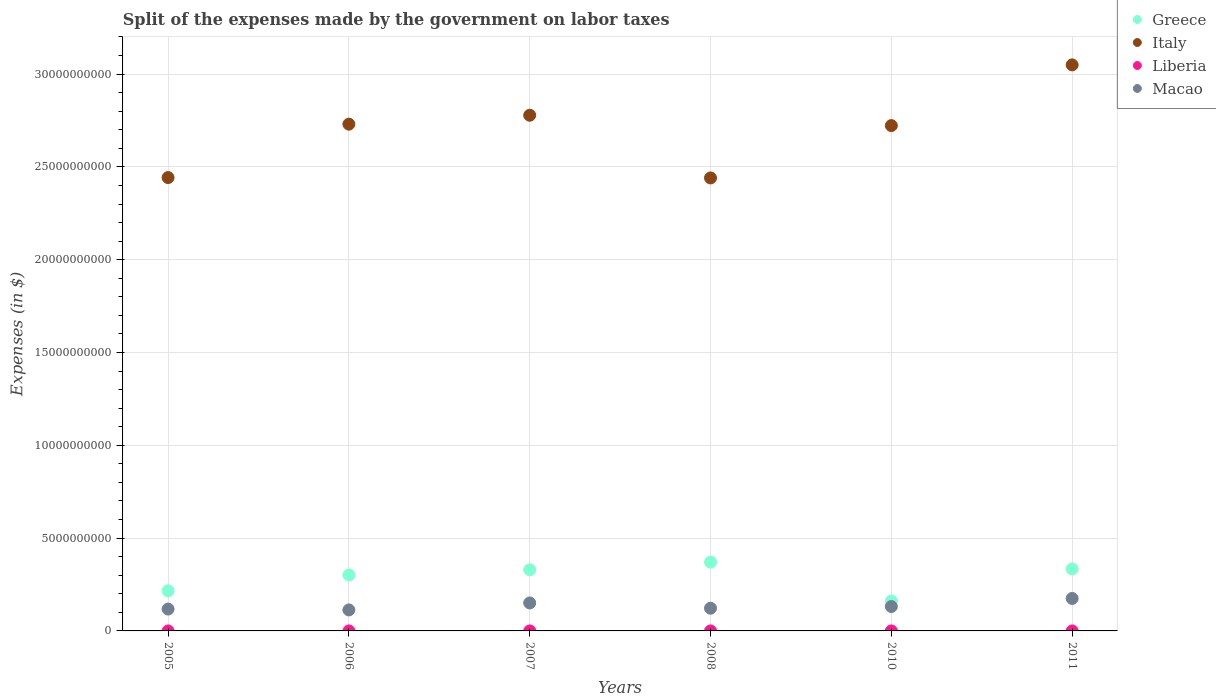How many different coloured dotlines are there?
Your response must be concise. 4. What is the expenses made by the government on labor taxes in Macao in 2010?
Make the answer very short. 1.31e+09. Across all years, what is the maximum expenses made by the government on labor taxes in Liberia?
Your answer should be very brief. 1.84e+05. Across all years, what is the minimum expenses made by the government on labor taxes in Macao?
Provide a short and direct response. 1.13e+09. In which year was the expenses made by the government on labor taxes in Liberia maximum?
Provide a short and direct response. 2010. What is the total expenses made by the government on labor taxes in Liberia in the graph?
Your answer should be very brief. 4.01e+05. What is the difference between the expenses made by the government on labor taxes in Macao in 2006 and that in 2007?
Offer a terse response. -3.76e+08. What is the difference between the expenses made by the government on labor taxes in Greece in 2006 and the expenses made by the government on labor taxes in Liberia in 2007?
Give a very brief answer. 3.01e+09. What is the average expenses made by the government on labor taxes in Italy per year?
Offer a very short reply. 2.69e+1. In the year 2011, what is the difference between the expenses made by the government on labor taxes in Liberia and expenses made by the government on labor taxes in Italy?
Give a very brief answer. -3.05e+1. In how many years, is the expenses made by the government on labor taxes in Macao greater than 19000000000 $?
Offer a terse response. 0. What is the ratio of the expenses made by the government on labor taxes in Italy in 2008 to that in 2010?
Give a very brief answer. 0.9. What is the difference between the highest and the second highest expenses made by the government on labor taxes in Macao?
Provide a succinct answer. 2.42e+08. What is the difference between the highest and the lowest expenses made by the government on labor taxes in Macao?
Your answer should be compact. 6.18e+08. Does the expenses made by the government on labor taxes in Italy monotonically increase over the years?
Ensure brevity in your answer.  No. How many years are there in the graph?
Give a very brief answer. 6. What is the difference between two consecutive major ticks on the Y-axis?
Your answer should be compact. 5.00e+09. Are the values on the major ticks of Y-axis written in scientific E-notation?
Make the answer very short. No. Does the graph contain any zero values?
Your response must be concise. No. Does the graph contain grids?
Ensure brevity in your answer.  Yes. How many legend labels are there?
Ensure brevity in your answer.  4. What is the title of the graph?
Keep it short and to the point. Split of the expenses made by the government on labor taxes. What is the label or title of the X-axis?
Provide a succinct answer. Years. What is the label or title of the Y-axis?
Give a very brief answer. Expenses (in $). What is the Expenses (in $) of Greece in 2005?
Keep it short and to the point. 2.16e+09. What is the Expenses (in $) in Italy in 2005?
Your answer should be very brief. 2.44e+1. What is the Expenses (in $) in Liberia in 2005?
Your response must be concise. 5831.56. What is the Expenses (in $) of Macao in 2005?
Offer a very short reply. 1.18e+09. What is the Expenses (in $) in Greece in 2006?
Offer a very short reply. 3.01e+09. What is the Expenses (in $) in Italy in 2006?
Ensure brevity in your answer.  2.73e+1. What is the Expenses (in $) in Liberia in 2006?
Your response must be concise. 4798.07. What is the Expenses (in $) in Macao in 2006?
Provide a succinct answer. 1.13e+09. What is the Expenses (in $) in Greece in 2007?
Ensure brevity in your answer.  3.29e+09. What is the Expenses (in $) of Italy in 2007?
Your answer should be compact. 2.78e+1. What is the Expenses (in $) of Liberia in 2007?
Offer a very short reply. 1.49e+04. What is the Expenses (in $) in Macao in 2007?
Your answer should be compact. 1.51e+09. What is the Expenses (in $) of Greece in 2008?
Your response must be concise. 3.71e+09. What is the Expenses (in $) of Italy in 2008?
Make the answer very short. 2.44e+1. What is the Expenses (in $) in Liberia in 2008?
Provide a succinct answer. 2.34e+04. What is the Expenses (in $) in Macao in 2008?
Offer a very short reply. 1.22e+09. What is the Expenses (in $) of Greece in 2010?
Your answer should be very brief. 1.61e+09. What is the Expenses (in $) of Italy in 2010?
Offer a terse response. 2.72e+1. What is the Expenses (in $) in Liberia in 2010?
Ensure brevity in your answer.  1.84e+05. What is the Expenses (in $) in Macao in 2010?
Your answer should be compact. 1.31e+09. What is the Expenses (in $) in Greece in 2011?
Your response must be concise. 3.34e+09. What is the Expenses (in $) of Italy in 2011?
Provide a short and direct response. 3.05e+1. What is the Expenses (in $) of Liberia in 2011?
Make the answer very short. 1.69e+05. What is the Expenses (in $) in Macao in 2011?
Ensure brevity in your answer.  1.75e+09. Across all years, what is the maximum Expenses (in $) of Greece?
Your answer should be very brief. 3.71e+09. Across all years, what is the maximum Expenses (in $) in Italy?
Provide a succinct answer. 3.05e+1. Across all years, what is the maximum Expenses (in $) in Liberia?
Offer a terse response. 1.84e+05. Across all years, what is the maximum Expenses (in $) in Macao?
Offer a very short reply. 1.75e+09. Across all years, what is the minimum Expenses (in $) of Greece?
Offer a terse response. 1.61e+09. Across all years, what is the minimum Expenses (in $) of Italy?
Give a very brief answer. 2.44e+1. Across all years, what is the minimum Expenses (in $) in Liberia?
Your answer should be very brief. 4798.07. Across all years, what is the minimum Expenses (in $) of Macao?
Ensure brevity in your answer.  1.13e+09. What is the total Expenses (in $) of Greece in the graph?
Give a very brief answer. 1.71e+1. What is the total Expenses (in $) in Italy in the graph?
Ensure brevity in your answer.  1.62e+11. What is the total Expenses (in $) in Liberia in the graph?
Ensure brevity in your answer.  4.01e+05. What is the total Expenses (in $) in Macao in the graph?
Your answer should be very brief. 8.10e+09. What is the difference between the Expenses (in $) of Greece in 2005 and that in 2006?
Keep it short and to the point. -8.53e+08. What is the difference between the Expenses (in $) of Italy in 2005 and that in 2006?
Your response must be concise. -2.88e+09. What is the difference between the Expenses (in $) in Liberia in 2005 and that in 2006?
Offer a very short reply. 1033.49. What is the difference between the Expenses (in $) in Macao in 2005 and that in 2006?
Offer a terse response. 4.80e+07. What is the difference between the Expenses (in $) in Greece in 2005 and that in 2007?
Your answer should be very brief. -1.13e+09. What is the difference between the Expenses (in $) in Italy in 2005 and that in 2007?
Ensure brevity in your answer.  -3.36e+09. What is the difference between the Expenses (in $) of Liberia in 2005 and that in 2007?
Your response must be concise. -9055.06. What is the difference between the Expenses (in $) of Macao in 2005 and that in 2007?
Offer a very short reply. -3.28e+08. What is the difference between the Expenses (in $) of Greece in 2005 and that in 2008?
Offer a very short reply. -1.55e+09. What is the difference between the Expenses (in $) of Italy in 2005 and that in 2008?
Your answer should be compact. 1.90e+07. What is the difference between the Expenses (in $) of Liberia in 2005 and that in 2008?
Your response must be concise. -1.76e+04. What is the difference between the Expenses (in $) in Macao in 2005 and that in 2008?
Your answer should be very brief. -4.48e+07. What is the difference between the Expenses (in $) of Greece in 2005 and that in 2010?
Ensure brevity in your answer.  5.49e+08. What is the difference between the Expenses (in $) in Italy in 2005 and that in 2010?
Your response must be concise. -2.80e+09. What is the difference between the Expenses (in $) in Liberia in 2005 and that in 2010?
Make the answer very short. -1.78e+05. What is the difference between the Expenses (in $) of Macao in 2005 and that in 2010?
Make the answer very short. -1.35e+08. What is the difference between the Expenses (in $) in Greece in 2005 and that in 2011?
Your answer should be compact. -1.18e+09. What is the difference between the Expenses (in $) of Italy in 2005 and that in 2011?
Provide a short and direct response. -6.07e+09. What is the difference between the Expenses (in $) in Liberia in 2005 and that in 2011?
Keep it short and to the point. -1.63e+05. What is the difference between the Expenses (in $) of Macao in 2005 and that in 2011?
Provide a short and direct response. -5.70e+08. What is the difference between the Expenses (in $) of Greece in 2006 and that in 2007?
Offer a terse response. -2.81e+08. What is the difference between the Expenses (in $) of Italy in 2006 and that in 2007?
Give a very brief answer. -4.80e+08. What is the difference between the Expenses (in $) of Liberia in 2006 and that in 2007?
Keep it short and to the point. -1.01e+04. What is the difference between the Expenses (in $) in Macao in 2006 and that in 2007?
Your answer should be compact. -3.76e+08. What is the difference between the Expenses (in $) of Greece in 2006 and that in 2008?
Your answer should be very brief. -6.94e+08. What is the difference between the Expenses (in $) of Italy in 2006 and that in 2008?
Your answer should be very brief. 2.90e+09. What is the difference between the Expenses (in $) of Liberia in 2006 and that in 2008?
Offer a terse response. -1.86e+04. What is the difference between the Expenses (in $) of Macao in 2006 and that in 2008?
Offer a terse response. -9.28e+07. What is the difference between the Expenses (in $) in Greece in 2006 and that in 2010?
Your answer should be compact. 1.40e+09. What is the difference between the Expenses (in $) of Italy in 2006 and that in 2010?
Provide a short and direct response. 7.70e+07. What is the difference between the Expenses (in $) in Liberia in 2006 and that in 2010?
Your response must be concise. -1.79e+05. What is the difference between the Expenses (in $) of Macao in 2006 and that in 2010?
Make the answer very short. -1.83e+08. What is the difference between the Expenses (in $) in Greece in 2006 and that in 2011?
Provide a short and direct response. -3.28e+08. What is the difference between the Expenses (in $) of Italy in 2006 and that in 2011?
Offer a terse response. -3.19e+09. What is the difference between the Expenses (in $) of Liberia in 2006 and that in 2011?
Keep it short and to the point. -1.64e+05. What is the difference between the Expenses (in $) in Macao in 2006 and that in 2011?
Your response must be concise. -6.18e+08. What is the difference between the Expenses (in $) of Greece in 2007 and that in 2008?
Your answer should be very brief. -4.13e+08. What is the difference between the Expenses (in $) of Italy in 2007 and that in 2008?
Give a very brief answer. 3.38e+09. What is the difference between the Expenses (in $) of Liberia in 2007 and that in 2008?
Offer a terse response. -8521.28. What is the difference between the Expenses (in $) of Macao in 2007 and that in 2008?
Provide a short and direct response. 2.83e+08. What is the difference between the Expenses (in $) in Greece in 2007 and that in 2010?
Offer a very short reply. 1.68e+09. What is the difference between the Expenses (in $) of Italy in 2007 and that in 2010?
Ensure brevity in your answer.  5.57e+08. What is the difference between the Expenses (in $) in Liberia in 2007 and that in 2010?
Provide a succinct answer. -1.69e+05. What is the difference between the Expenses (in $) of Macao in 2007 and that in 2010?
Provide a short and direct response. 1.93e+08. What is the difference between the Expenses (in $) of Greece in 2007 and that in 2011?
Your answer should be very brief. -4.70e+07. What is the difference between the Expenses (in $) of Italy in 2007 and that in 2011?
Ensure brevity in your answer.  -2.71e+09. What is the difference between the Expenses (in $) of Liberia in 2007 and that in 2011?
Offer a very short reply. -1.54e+05. What is the difference between the Expenses (in $) in Macao in 2007 and that in 2011?
Offer a terse response. -2.42e+08. What is the difference between the Expenses (in $) of Greece in 2008 and that in 2010?
Give a very brief answer. 2.10e+09. What is the difference between the Expenses (in $) of Italy in 2008 and that in 2010?
Keep it short and to the point. -2.82e+09. What is the difference between the Expenses (in $) of Liberia in 2008 and that in 2010?
Give a very brief answer. -1.61e+05. What is the difference between the Expenses (in $) in Macao in 2008 and that in 2010?
Your answer should be very brief. -9.05e+07. What is the difference between the Expenses (in $) in Greece in 2008 and that in 2011?
Make the answer very short. 3.66e+08. What is the difference between the Expenses (in $) in Italy in 2008 and that in 2011?
Keep it short and to the point. -6.09e+09. What is the difference between the Expenses (in $) of Liberia in 2008 and that in 2011?
Your response must be concise. -1.45e+05. What is the difference between the Expenses (in $) of Macao in 2008 and that in 2011?
Offer a terse response. -5.25e+08. What is the difference between the Expenses (in $) of Greece in 2010 and that in 2011?
Keep it short and to the point. -1.73e+09. What is the difference between the Expenses (in $) in Italy in 2010 and that in 2011?
Your answer should be compact. -3.27e+09. What is the difference between the Expenses (in $) of Liberia in 2010 and that in 2011?
Provide a succinct answer. 1.55e+04. What is the difference between the Expenses (in $) of Macao in 2010 and that in 2011?
Make the answer very short. -4.35e+08. What is the difference between the Expenses (in $) of Greece in 2005 and the Expenses (in $) of Italy in 2006?
Provide a succinct answer. -2.51e+1. What is the difference between the Expenses (in $) in Greece in 2005 and the Expenses (in $) in Liberia in 2006?
Provide a short and direct response. 2.16e+09. What is the difference between the Expenses (in $) in Greece in 2005 and the Expenses (in $) in Macao in 2006?
Give a very brief answer. 1.03e+09. What is the difference between the Expenses (in $) of Italy in 2005 and the Expenses (in $) of Liberia in 2006?
Provide a succinct answer. 2.44e+1. What is the difference between the Expenses (in $) of Italy in 2005 and the Expenses (in $) of Macao in 2006?
Ensure brevity in your answer.  2.33e+1. What is the difference between the Expenses (in $) of Liberia in 2005 and the Expenses (in $) of Macao in 2006?
Your answer should be compact. -1.13e+09. What is the difference between the Expenses (in $) in Greece in 2005 and the Expenses (in $) in Italy in 2007?
Provide a short and direct response. -2.56e+1. What is the difference between the Expenses (in $) of Greece in 2005 and the Expenses (in $) of Liberia in 2007?
Provide a short and direct response. 2.16e+09. What is the difference between the Expenses (in $) in Greece in 2005 and the Expenses (in $) in Macao in 2007?
Your answer should be compact. 6.53e+08. What is the difference between the Expenses (in $) in Italy in 2005 and the Expenses (in $) in Liberia in 2007?
Your answer should be compact. 2.44e+1. What is the difference between the Expenses (in $) in Italy in 2005 and the Expenses (in $) in Macao in 2007?
Your answer should be very brief. 2.29e+1. What is the difference between the Expenses (in $) of Liberia in 2005 and the Expenses (in $) of Macao in 2007?
Keep it short and to the point. -1.51e+09. What is the difference between the Expenses (in $) in Greece in 2005 and the Expenses (in $) in Italy in 2008?
Provide a short and direct response. -2.22e+1. What is the difference between the Expenses (in $) of Greece in 2005 and the Expenses (in $) of Liberia in 2008?
Offer a very short reply. 2.16e+09. What is the difference between the Expenses (in $) in Greece in 2005 and the Expenses (in $) in Macao in 2008?
Provide a short and direct response. 9.36e+08. What is the difference between the Expenses (in $) in Italy in 2005 and the Expenses (in $) in Liberia in 2008?
Your response must be concise. 2.44e+1. What is the difference between the Expenses (in $) of Italy in 2005 and the Expenses (in $) of Macao in 2008?
Offer a very short reply. 2.32e+1. What is the difference between the Expenses (in $) of Liberia in 2005 and the Expenses (in $) of Macao in 2008?
Your answer should be compact. -1.22e+09. What is the difference between the Expenses (in $) in Greece in 2005 and the Expenses (in $) in Italy in 2010?
Your answer should be compact. -2.51e+1. What is the difference between the Expenses (in $) of Greece in 2005 and the Expenses (in $) of Liberia in 2010?
Give a very brief answer. 2.16e+09. What is the difference between the Expenses (in $) of Greece in 2005 and the Expenses (in $) of Macao in 2010?
Ensure brevity in your answer.  8.46e+08. What is the difference between the Expenses (in $) in Italy in 2005 and the Expenses (in $) in Liberia in 2010?
Your answer should be compact. 2.44e+1. What is the difference between the Expenses (in $) of Italy in 2005 and the Expenses (in $) of Macao in 2010?
Make the answer very short. 2.31e+1. What is the difference between the Expenses (in $) in Liberia in 2005 and the Expenses (in $) in Macao in 2010?
Make the answer very short. -1.31e+09. What is the difference between the Expenses (in $) in Greece in 2005 and the Expenses (in $) in Italy in 2011?
Ensure brevity in your answer.  -2.83e+1. What is the difference between the Expenses (in $) in Greece in 2005 and the Expenses (in $) in Liberia in 2011?
Make the answer very short. 2.16e+09. What is the difference between the Expenses (in $) in Greece in 2005 and the Expenses (in $) in Macao in 2011?
Make the answer very short. 4.11e+08. What is the difference between the Expenses (in $) in Italy in 2005 and the Expenses (in $) in Liberia in 2011?
Your response must be concise. 2.44e+1. What is the difference between the Expenses (in $) in Italy in 2005 and the Expenses (in $) in Macao in 2011?
Your answer should be compact. 2.27e+1. What is the difference between the Expenses (in $) in Liberia in 2005 and the Expenses (in $) in Macao in 2011?
Provide a succinct answer. -1.75e+09. What is the difference between the Expenses (in $) of Greece in 2006 and the Expenses (in $) of Italy in 2007?
Provide a short and direct response. -2.48e+1. What is the difference between the Expenses (in $) in Greece in 2006 and the Expenses (in $) in Liberia in 2007?
Ensure brevity in your answer.  3.01e+09. What is the difference between the Expenses (in $) in Greece in 2006 and the Expenses (in $) in Macao in 2007?
Give a very brief answer. 1.51e+09. What is the difference between the Expenses (in $) in Italy in 2006 and the Expenses (in $) in Liberia in 2007?
Your answer should be compact. 2.73e+1. What is the difference between the Expenses (in $) in Italy in 2006 and the Expenses (in $) in Macao in 2007?
Provide a succinct answer. 2.58e+1. What is the difference between the Expenses (in $) in Liberia in 2006 and the Expenses (in $) in Macao in 2007?
Ensure brevity in your answer.  -1.51e+09. What is the difference between the Expenses (in $) in Greece in 2006 and the Expenses (in $) in Italy in 2008?
Give a very brief answer. -2.14e+1. What is the difference between the Expenses (in $) in Greece in 2006 and the Expenses (in $) in Liberia in 2008?
Your answer should be compact. 3.01e+09. What is the difference between the Expenses (in $) in Greece in 2006 and the Expenses (in $) in Macao in 2008?
Offer a very short reply. 1.79e+09. What is the difference between the Expenses (in $) of Italy in 2006 and the Expenses (in $) of Liberia in 2008?
Your answer should be compact. 2.73e+1. What is the difference between the Expenses (in $) in Italy in 2006 and the Expenses (in $) in Macao in 2008?
Provide a short and direct response. 2.61e+1. What is the difference between the Expenses (in $) of Liberia in 2006 and the Expenses (in $) of Macao in 2008?
Your answer should be compact. -1.22e+09. What is the difference between the Expenses (in $) of Greece in 2006 and the Expenses (in $) of Italy in 2010?
Provide a succinct answer. -2.42e+1. What is the difference between the Expenses (in $) in Greece in 2006 and the Expenses (in $) in Liberia in 2010?
Give a very brief answer. 3.01e+09. What is the difference between the Expenses (in $) in Greece in 2006 and the Expenses (in $) in Macao in 2010?
Provide a short and direct response. 1.70e+09. What is the difference between the Expenses (in $) of Italy in 2006 and the Expenses (in $) of Liberia in 2010?
Your response must be concise. 2.73e+1. What is the difference between the Expenses (in $) in Italy in 2006 and the Expenses (in $) in Macao in 2010?
Your response must be concise. 2.60e+1. What is the difference between the Expenses (in $) of Liberia in 2006 and the Expenses (in $) of Macao in 2010?
Give a very brief answer. -1.31e+09. What is the difference between the Expenses (in $) of Greece in 2006 and the Expenses (in $) of Italy in 2011?
Ensure brevity in your answer.  -2.75e+1. What is the difference between the Expenses (in $) in Greece in 2006 and the Expenses (in $) in Liberia in 2011?
Provide a short and direct response. 3.01e+09. What is the difference between the Expenses (in $) in Greece in 2006 and the Expenses (in $) in Macao in 2011?
Make the answer very short. 1.26e+09. What is the difference between the Expenses (in $) of Italy in 2006 and the Expenses (in $) of Liberia in 2011?
Keep it short and to the point. 2.73e+1. What is the difference between the Expenses (in $) in Italy in 2006 and the Expenses (in $) in Macao in 2011?
Your answer should be compact. 2.56e+1. What is the difference between the Expenses (in $) of Liberia in 2006 and the Expenses (in $) of Macao in 2011?
Provide a succinct answer. -1.75e+09. What is the difference between the Expenses (in $) of Greece in 2007 and the Expenses (in $) of Italy in 2008?
Your answer should be very brief. -2.11e+1. What is the difference between the Expenses (in $) in Greece in 2007 and the Expenses (in $) in Liberia in 2008?
Your answer should be compact. 3.29e+09. What is the difference between the Expenses (in $) of Greece in 2007 and the Expenses (in $) of Macao in 2008?
Give a very brief answer. 2.07e+09. What is the difference between the Expenses (in $) of Italy in 2007 and the Expenses (in $) of Liberia in 2008?
Keep it short and to the point. 2.78e+1. What is the difference between the Expenses (in $) in Italy in 2007 and the Expenses (in $) in Macao in 2008?
Ensure brevity in your answer.  2.66e+1. What is the difference between the Expenses (in $) of Liberia in 2007 and the Expenses (in $) of Macao in 2008?
Ensure brevity in your answer.  -1.22e+09. What is the difference between the Expenses (in $) of Greece in 2007 and the Expenses (in $) of Italy in 2010?
Your response must be concise. -2.39e+1. What is the difference between the Expenses (in $) in Greece in 2007 and the Expenses (in $) in Liberia in 2010?
Ensure brevity in your answer.  3.29e+09. What is the difference between the Expenses (in $) in Greece in 2007 and the Expenses (in $) in Macao in 2010?
Provide a succinct answer. 1.98e+09. What is the difference between the Expenses (in $) of Italy in 2007 and the Expenses (in $) of Liberia in 2010?
Offer a very short reply. 2.78e+1. What is the difference between the Expenses (in $) of Italy in 2007 and the Expenses (in $) of Macao in 2010?
Ensure brevity in your answer.  2.65e+1. What is the difference between the Expenses (in $) in Liberia in 2007 and the Expenses (in $) in Macao in 2010?
Give a very brief answer. -1.31e+09. What is the difference between the Expenses (in $) of Greece in 2007 and the Expenses (in $) of Italy in 2011?
Offer a very short reply. -2.72e+1. What is the difference between the Expenses (in $) of Greece in 2007 and the Expenses (in $) of Liberia in 2011?
Provide a succinct answer. 3.29e+09. What is the difference between the Expenses (in $) in Greece in 2007 and the Expenses (in $) in Macao in 2011?
Give a very brief answer. 1.54e+09. What is the difference between the Expenses (in $) in Italy in 2007 and the Expenses (in $) in Liberia in 2011?
Give a very brief answer. 2.78e+1. What is the difference between the Expenses (in $) in Italy in 2007 and the Expenses (in $) in Macao in 2011?
Give a very brief answer. 2.60e+1. What is the difference between the Expenses (in $) in Liberia in 2007 and the Expenses (in $) in Macao in 2011?
Give a very brief answer. -1.75e+09. What is the difference between the Expenses (in $) in Greece in 2008 and the Expenses (in $) in Italy in 2010?
Ensure brevity in your answer.  -2.35e+1. What is the difference between the Expenses (in $) of Greece in 2008 and the Expenses (in $) of Liberia in 2010?
Offer a terse response. 3.71e+09. What is the difference between the Expenses (in $) in Greece in 2008 and the Expenses (in $) in Macao in 2010?
Ensure brevity in your answer.  2.39e+09. What is the difference between the Expenses (in $) in Italy in 2008 and the Expenses (in $) in Liberia in 2010?
Your answer should be very brief. 2.44e+1. What is the difference between the Expenses (in $) in Italy in 2008 and the Expenses (in $) in Macao in 2010?
Provide a succinct answer. 2.31e+1. What is the difference between the Expenses (in $) in Liberia in 2008 and the Expenses (in $) in Macao in 2010?
Your response must be concise. -1.31e+09. What is the difference between the Expenses (in $) in Greece in 2008 and the Expenses (in $) in Italy in 2011?
Offer a terse response. -2.68e+1. What is the difference between the Expenses (in $) in Greece in 2008 and the Expenses (in $) in Liberia in 2011?
Provide a short and direct response. 3.71e+09. What is the difference between the Expenses (in $) of Greece in 2008 and the Expenses (in $) of Macao in 2011?
Ensure brevity in your answer.  1.96e+09. What is the difference between the Expenses (in $) of Italy in 2008 and the Expenses (in $) of Liberia in 2011?
Provide a succinct answer. 2.44e+1. What is the difference between the Expenses (in $) of Italy in 2008 and the Expenses (in $) of Macao in 2011?
Give a very brief answer. 2.27e+1. What is the difference between the Expenses (in $) in Liberia in 2008 and the Expenses (in $) in Macao in 2011?
Ensure brevity in your answer.  -1.75e+09. What is the difference between the Expenses (in $) in Greece in 2010 and the Expenses (in $) in Italy in 2011?
Offer a very short reply. -2.89e+1. What is the difference between the Expenses (in $) in Greece in 2010 and the Expenses (in $) in Liberia in 2011?
Your response must be concise. 1.61e+09. What is the difference between the Expenses (in $) in Greece in 2010 and the Expenses (in $) in Macao in 2011?
Your response must be concise. -1.38e+08. What is the difference between the Expenses (in $) in Italy in 2010 and the Expenses (in $) in Liberia in 2011?
Your answer should be very brief. 2.72e+1. What is the difference between the Expenses (in $) in Italy in 2010 and the Expenses (in $) in Macao in 2011?
Make the answer very short. 2.55e+1. What is the difference between the Expenses (in $) of Liberia in 2010 and the Expenses (in $) of Macao in 2011?
Your response must be concise. -1.75e+09. What is the average Expenses (in $) in Greece per year?
Your answer should be very brief. 2.85e+09. What is the average Expenses (in $) of Italy per year?
Make the answer very short. 2.69e+1. What is the average Expenses (in $) of Liberia per year?
Provide a succinct answer. 6.69e+04. What is the average Expenses (in $) in Macao per year?
Provide a succinct answer. 1.35e+09. In the year 2005, what is the difference between the Expenses (in $) of Greece and Expenses (in $) of Italy?
Your answer should be compact. -2.23e+1. In the year 2005, what is the difference between the Expenses (in $) in Greece and Expenses (in $) in Liberia?
Give a very brief answer. 2.16e+09. In the year 2005, what is the difference between the Expenses (in $) in Greece and Expenses (in $) in Macao?
Provide a short and direct response. 9.81e+08. In the year 2005, what is the difference between the Expenses (in $) in Italy and Expenses (in $) in Liberia?
Ensure brevity in your answer.  2.44e+1. In the year 2005, what is the difference between the Expenses (in $) in Italy and Expenses (in $) in Macao?
Offer a very short reply. 2.32e+1. In the year 2005, what is the difference between the Expenses (in $) of Liberia and Expenses (in $) of Macao?
Offer a terse response. -1.18e+09. In the year 2006, what is the difference between the Expenses (in $) of Greece and Expenses (in $) of Italy?
Your answer should be very brief. -2.43e+1. In the year 2006, what is the difference between the Expenses (in $) of Greece and Expenses (in $) of Liberia?
Your answer should be compact. 3.01e+09. In the year 2006, what is the difference between the Expenses (in $) of Greece and Expenses (in $) of Macao?
Provide a succinct answer. 1.88e+09. In the year 2006, what is the difference between the Expenses (in $) in Italy and Expenses (in $) in Liberia?
Make the answer very short. 2.73e+1. In the year 2006, what is the difference between the Expenses (in $) of Italy and Expenses (in $) of Macao?
Make the answer very short. 2.62e+1. In the year 2006, what is the difference between the Expenses (in $) in Liberia and Expenses (in $) in Macao?
Your answer should be very brief. -1.13e+09. In the year 2007, what is the difference between the Expenses (in $) of Greece and Expenses (in $) of Italy?
Make the answer very short. -2.45e+1. In the year 2007, what is the difference between the Expenses (in $) in Greece and Expenses (in $) in Liberia?
Offer a very short reply. 3.29e+09. In the year 2007, what is the difference between the Expenses (in $) of Greece and Expenses (in $) of Macao?
Ensure brevity in your answer.  1.79e+09. In the year 2007, what is the difference between the Expenses (in $) of Italy and Expenses (in $) of Liberia?
Make the answer very short. 2.78e+1. In the year 2007, what is the difference between the Expenses (in $) of Italy and Expenses (in $) of Macao?
Make the answer very short. 2.63e+1. In the year 2007, what is the difference between the Expenses (in $) of Liberia and Expenses (in $) of Macao?
Offer a very short reply. -1.51e+09. In the year 2008, what is the difference between the Expenses (in $) in Greece and Expenses (in $) in Italy?
Provide a short and direct response. -2.07e+1. In the year 2008, what is the difference between the Expenses (in $) of Greece and Expenses (in $) of Liberia?
Provide a short and direct response. 3.71e+09. In the year 2008, what is the difference between the Expenses (in $) of Greece and Expenses (in $) of Macao?
Give a very brief answer. 2.48e+09. In the year 2008, what is the difference between the Expenses (in $) of Italy and Expenses (in $) of Liberia?
Your response must be concise. 2.44e+1. In the year 2008, what is the difference between the Expenses (in $) in Italy and Expenses (in $) in Macao?
Make the answer very short. 2.32e+1. In the year 2008, what is the difference between the Expenses (in $) in Liberia and Expenses (in $) in Macao?
Give a very brief answer. -1.22e+09. In the year 2010, what is the difference between the Expenses (in $) in Greece and Expenses (in $) in Italy?
Offer a very short reply. -2.56e+1. In the year 2010, what is the difference between the Expenses (in $) of Greece and Expenses (in $) of Liberia?
Ensure brevity in your answer.  1.61e+09. In the year 2010, what is the difference between the Expenses (in $) of Greece and Expenses (in $) of Macao?
Your response must be concise. 2.97e+08. In the year 2010, what is the difference between the Expenses (in $) in Italy and Expenses (in $) in Liberia?
Offer a terse response. 2.72e+1. In the year 2010, what is the difference between the Expenses (in $) of Italy and Expenses (in $) of Macao?
Your response must be concise. 2.59e+1. In the year 2010, what is the difference between the Expenses (in $) of Liberia and Expenses (in $) of Macao?
Offer a very short reply. -1.31e+09. In the year 2011, what is the difference between the Expenses (in $) in Greece and Expenses (in $) in Italy?
Your answer should be compact. -2.72e+1. In the year 2011, what is the difference between the Expenses (in $) in Greece and Expenses (in $) in Liberia?
Provide a succinct answer. 3.34e+09. In the year 2011, what is the difference between the Expenses (in $) of Greece and Expenses (in $) of Macao?
Your response must be concise. 1.59e+09. In the year 2011, what is the difference between the Expenses (in $) of Italy and Expenses (in $) of Liberia?
Your answer should be very brief. 3.05e+1. In the year 2011, what is the difference between the Expenses (in $) in Italy and Expenses (in $) in Macao?
Offer a terse response. 2.87e+1. In the year 2011, what is the difference between the Expenses (in $) of Liberia and Expenses (in $) of Macao?
Offer a terse response. -1.75e+09. What is the ratio of the Expenses (in $) in Greece in 2005 to that in 2006?
Your answer should be compact. 0.72. What is the ratio of the Expenses (in $) in Italy in 2005 to that in 2006?
Your answer should be very brief. 0.89. What is the ratio of the Expenses (in $) of Liberia in 2005 to that in 2006?
Ensure brevity in your answer.  1.22. What is the ratio of the Expenses (in $) in Macao in 2005 to that in 2006?
Keep it short and to the point. 1.04. What is the ratio of the Expenses (in $) in Greece in 2005 to that in 2007?
Your response must be concise. 0.66. What is the ratio of the Expenses (in $) of Italy in 2005 to that in 2007?
Give a very brief answer. 0.88. What is the ratio of the Expenses (in $) in Liberia in 2005 to that in 2007?
Offer a terse response. 0.39. What is the ratio of the Expenses (in $) in Macao in 2005 to that in 2007?
Your response must be concise. 0.78. What is the ratio of the Expenses (in $) of Greece in 2005 to that in 2008?
Offer a terse response. 0.58. What is the ratio of the Expenses (in $) in Liberia in 2005 to that in 2008?
Provide a succinct answer. 0.25. What is the ratio of the Expenses (in $) in Macao in 2005 to that in 2008?
Your response must be concise. 0.96. What is the ratio of the Expenses (in $) in Greece in 2005 to that in 2010?
Keep it short and to the point. 1.34. What is the ratio of the Expenses (in $) in Italy in 2005 to that in 2010?
Provide a succinct answer. 0.9. What is the ratio of the Expenses (in $) of Liberia in 2005 to that in 2010?
Ensure brevity in your answer.  0.03. What is the ratio of the Expenses (in $) of Macao in 2005 to that in 2010?
Provide a short and direct response. 0.9. What is the ratio of the Expenses (in $) of Greece in 2005 to that in 2011?
Keep it short and to the point. 0.65. What is the ratio of the Expenses (in $) in Italy in 2005 to that in 2011?
Your response must be concise. 0.8. What is the ratio of the Expenses (in $) in Liberia in 2005 to that in 2011?
Provide a short and direct response. 0.03. What is the ratio of the Expenses (in $) in Macao in 2005 to that in 2011?
Your response must be concise. 0.67. What is the ratio of the Expenses (in $) of Greece in 2006 to that in 2007?
Keep it short and to the point. 0.91. What is the ratio of the Expenses (in $) of Italy in 2006 to that in 2007?
Your answer should be very brief. 0.98. What is the ratio of the Expenses (in $) of Liberia in 2006 to that in 2007?
Your answer should be compact. 0.32. What is the ratio of the Expenses (in $) in Macao in 2006 to that in 2007?
Your answer should be compact. 0.75. What is the ratio of the Expenses (in $) of Greece in 2006 to that in 2008?
Provide a short and direct response. 0.81. What is the ratio of the Expenses (in $) in Italy in 2006 to that in 2008?
Offer a terse response. 1.12. What is the ratio of the Expenses (in $) of Liberia in 2006 to that in 2008?
Provide a succinct answer. 0.2. What is the ratio of the Expenses (in $) in Macao in 2006 to that in 2008?
Provide a succinct answer. 0.92. What is the ratio of the Expenses (in $) in Greece in 2006 to that in 2010?
Make the answer very short. 1.87. What is the ratio of the Expenses (in $) in Italy in 2006 to that in 2010?
Make the answer very short. 1. What is the ratio of the Expenses (in $) of Liberia in 2006 to that in 2010?
Your response must be concise. 0.03. What is the ratio of the Expenses (in $) in Macao in 2006 to that in 2010?
Make the answer very short. 0.86. What is the ratio of the Expenses (in $) of Greece in 2006 to that in 2011?
Make the answer very short. 0.9. What is the ratio of the Expenses (in $) of Italy in 2006 to that in 2011?
Provide a succinct answer. 0.9. What is the ratio of the Expenses (in $) of Liberia in 2006 to that in 2011?
Offer a terse response. 0.03. What is the ratio of the Expenses (in $) in Macao in 2006 to that in 2011?
Your answer should be very brief. 0.65. What is the ratio of the Expenses (in $) of Greece in 2007 to that in 2008?
Ensure brevity in your answer.  0.89. What is the ratio of the Expenses (in $) in Italy in 2007 to that in 2008?
Give a very brief answer. 1.14. What is the ratio of the Expenses (in $) of Liberia in 2007 to that in 2008?
Your answer should be compact. 0.64. What is the ratio of the Expenses (in $) in Macao in 2007 to that in 2008?
Make the answer very short. 1.23. What is the ratio of the Expenses (in $) of Greece in 2007 to that in 2010?
Offer a terse response. 2.04. What is the ratio of the Expenses (in $) of Italy in 2007 to that in 2010?
Provide a succinct answer. 1.02. What is the ratio of the Expenses (in $) in Liberia in 2007 to that in 2010?
Offer a very short reply. 0.08. What is the ratio of the Expenses (in $) of Macao in 2007 to that in 2010?
Make the answer very short. 1.15. What is the ratio of the Expenses (in $) in Greece in 2007 to that in 2011?
Offer a very short reply. 0.99. What is the ratio of the Expenses (in $) in Italy in 2007 to that in 2011?
Offer a very short reply. 0.91. What is the ratio of the Expenses (in $) in Liberia in 2007 to that in 2011?
Offer a very short reply. 0.09. What is the ratio of the Expenses (in $) in Macao in 2007 to that in 2011?
Offer a very short reply. 0.86. What is the ratio of the Expenses (in $) of Greece in 2008 to that in 2010?
Your answer should be compact. 2.3. What is the ratio of the Expenses (in $) of Italy in 2008 to that in 2010?
Offer a terse response. 0.9. What is the ratio of the Expenses (in $) in Liberia in 2008 to that in 2010?
Provide a succinct answer. 0.13. What is the ratio of the Expenses (in $) in Macao in 2008 to that in 2010?
Offer a very short reply. 0.93. What is the ratio of the Expenses (in $) of Greece in 2008 to that in 2011?
Offer a very short reply. 1.11. What is the ratio of the Expenses (in $) in Italy in 2008 to that in 2011?
Provide a succinct answer. 0.8. What is the ratio of the Expenses (in $) of Liberia in 2008 to that in 2011?
Your answer should be very brief. 0.14. What is the ratio of the Expenses (in $) of Macao in 2008 to that in 2011?
Your response must be concise. 0.7. What is the ratio of the Expenses (in $) in Greece in 2010 to that in 2011?
Your answer should be compact. 0.48. What is the ratio of the Expenses (in $) of Italy in 2010 to that in 2011?
Offer a terse response. 0.89. What is the ratio of the Expenses (in $) in Liberia in 2010 to that in 2011?
Keep it short and to the point. 1.09. What is the ratio of the Expenses (in $) in Macao in 2010 to that in 2011?
Your answer should be compact. 0.75. What is the difference between the highest and the second highest Expenses (in $) of Greece?
Keep it short and to the point. 3.66e+08. What is the difference between the highest and the second highest Expenses (in $) in Italy?
Offer a very short reply. 2.71e+09. What is the difference between the highest and the second highest Expenses (in $) in Liberia?
Your answer should be compact. 1.55e+04. What is the difference between the highest and the second highest Expenses (in $) in Macao?
Your response must be concise. 2.42e+08. What is the difference between the highest and the lowest Expenses (in $) in Greece?
Make the answer very short. 2.10e+09. What is the difference between the highest and the lowest Expenses (in $) in Italy?
Provide a short and direct response. 6.09e+09. What is the difference between the highest and the lowest Expenses (in $) of Liberia?
Keep it short and to the point. 1.79e+05. What is the difference between the highest and the lowest Expenses (in $) in Macao?
Make the answer very short. 6.18e+08. 